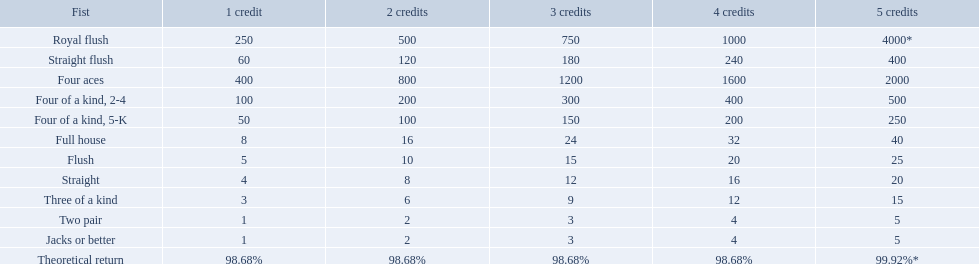What are the hands in super aces? Royal flush, Straight flush, Four aces, Four of a kind, 2-4, Four of a kind, 5-K, Full house, Flush, Straight, Three of a kind, Two pair, Jacks or better. What hand gives the highest credits? Royal flush. What is the values in the 5 credits area? 4000*, 400, 2000, 500, 250, 40, 25, 20, 15, 5, 5. Which of these is for a four of a kind? 500, 250. What is the higher value? 500. What hand is this for Four of a kind, 2-4. Which hand is lower than straight flush? Four aces. Which hand is lower than four aces? Four of a kind, 2-4. Which hand is higher out of straight and flush? Flush. 